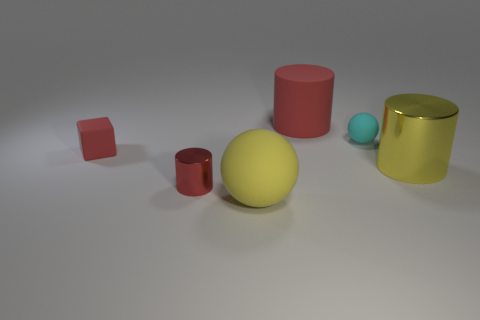Subtract all red cylinders. How many cylinders are left? 1 Add 4 small red matte objects. How many objects exist? 10 Subtract all yellow cylinders. How many cylinders are left? 2 Add 3 small blocks. How many small blocks exist? 4 Subtract 0 yellow cubes. How many objects are left? 6 Subtract all balls. How many objects are left? 4 Subtract 1 spheres. How many spheres are left? 1 Subtract all purple spheres. Subtract all blue cylinders. How many spheres are left? 2 Subtract all gray cubes. How many cyan balls are left? 1 Subtract all blue cylinders. Subtract all balls. How many objects are left? 4 